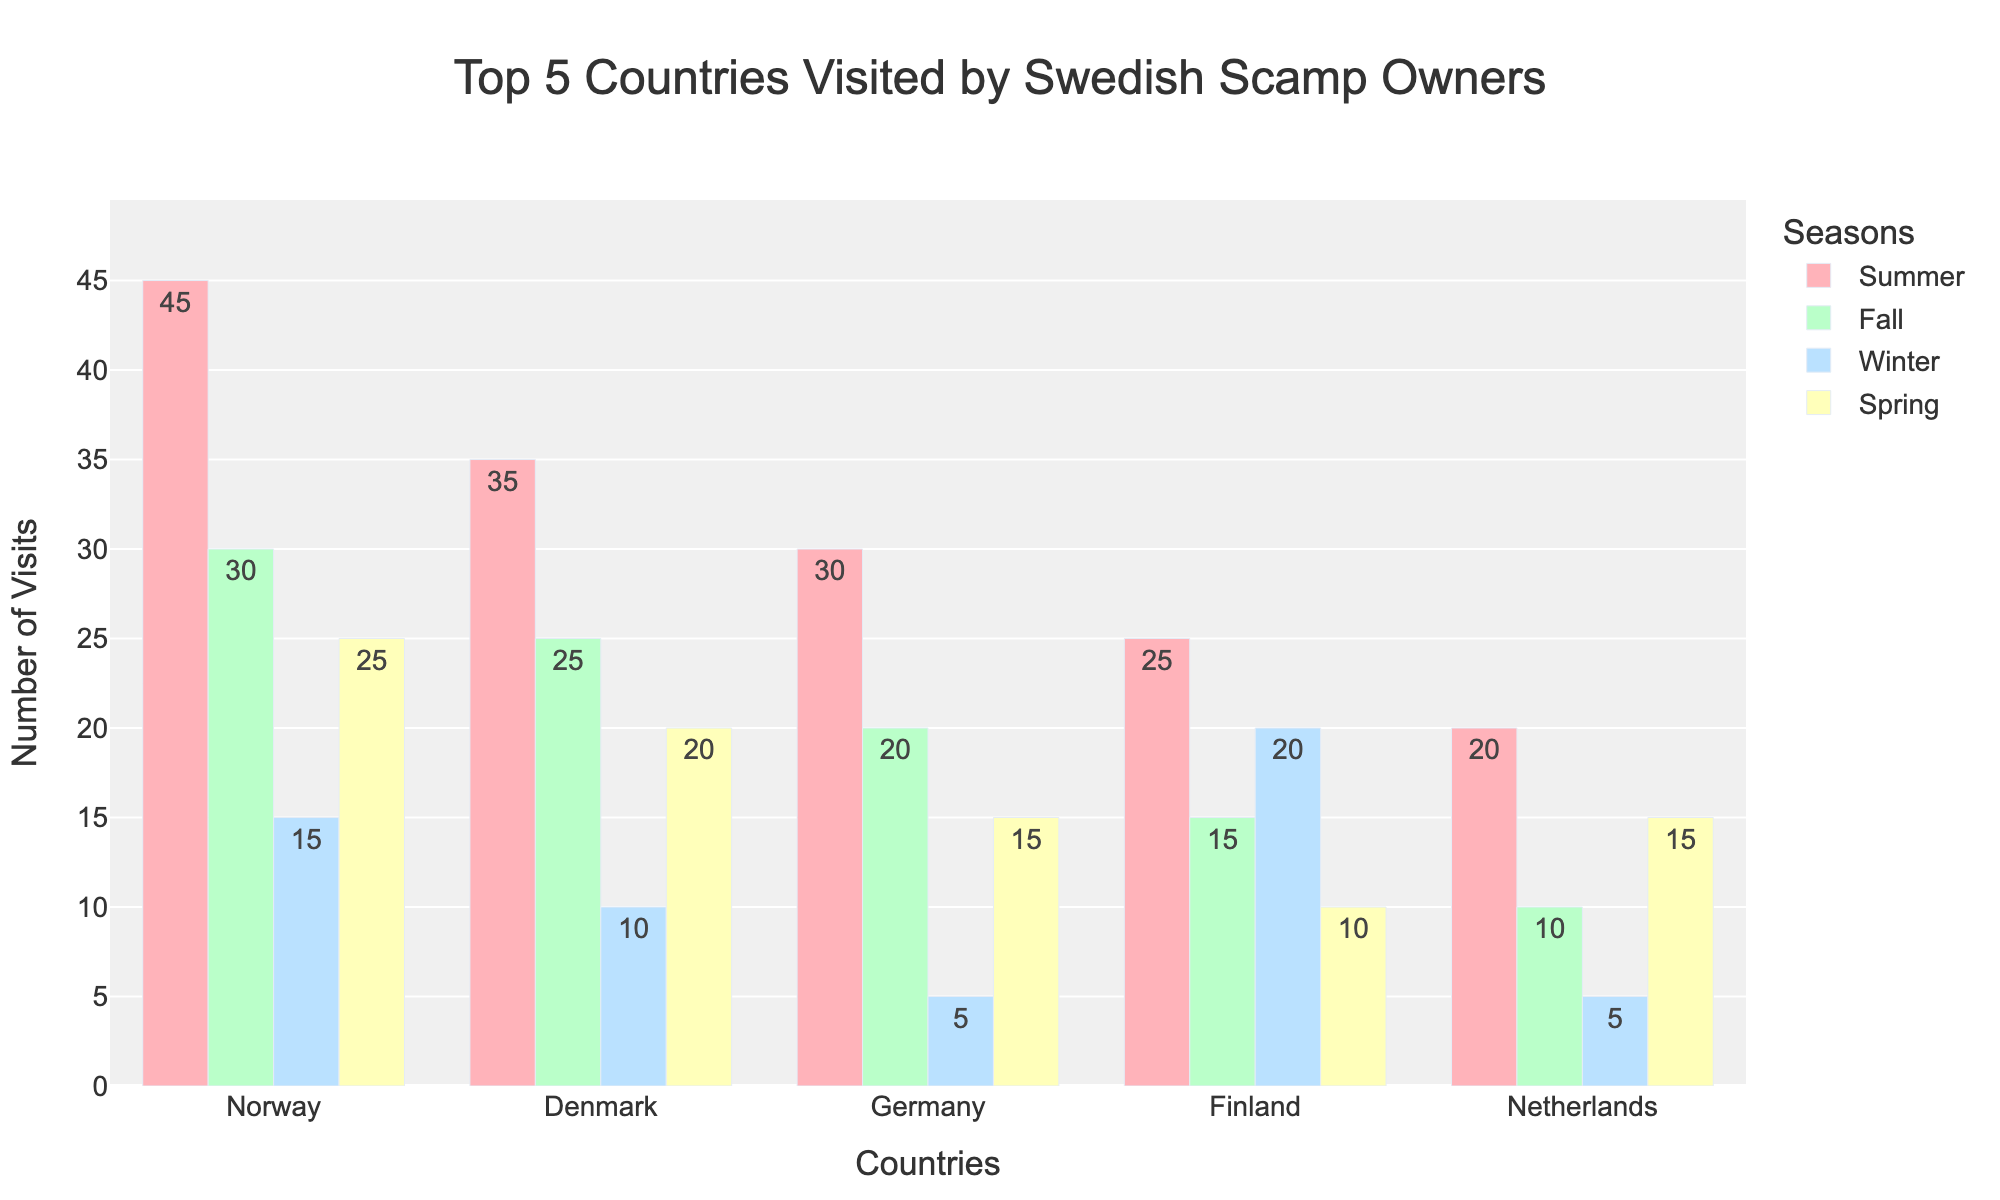Which country has the highest number of visits in Winter? By observing the lengths of the bars corresponding to Winter, we can see that Finland has the longest bar, indicating the highest number of visits.
Answer: Finland How many more visits does Norway have in Summer compared to the Netherlands in Fall? First, observe the Summer visits for Norway, which is 45. Then, observe the Fall visits for the Netherlands, which is 10. The difference is 45 - 10 = 35.
Answer: 35 In which season does Denmark have the least visits? By comparing the heights of the four bars representing Denmark, we can see that the Winter bar is the shortest, indicating the least number of visits.
Answer: Winter What's the total number of visits to Germany across all seasons? Add the number of visits for Germany in all seasons: Summer (30), Fall (20), Winter (5), and Spring (15). The total is 30 + 20 + 5 + 15 = 70.
Answer: 70 Which country has the most balanced number of visits across all seasons? We need to look for the country with bars of similar height across all seasons. By analyzing the chart, Germany appears to have bars of more equal heights compared to other countries.
Answer: Germany Compare Spring visits to Finland and the Netherlands. Which country has more and by how much? First, observe the Spring visits for Finland (10) and the Netherlands (15). The difference is 15 - 10 = 5, so the Netherlands has 5 more visits.
Answer: The Netherlands, 5 Which season has the highest number of total visits across all countries? Sum the visits for each season across all countries. For Summer: 45+35+30+25+20=155. For Fall: 30+25+20+15+10=100. For Winter: 15+10+5+20+5=55. For Spring: 25+20+15+10+15=85. Summer has the highest total.
Answer: Summer What is the difference in total visits between the top-visited and least-visited seasons for Sweden’s Scamp owners? Sum visits for all countries for each season as follows: Summer (45+35+30+25+20=155), Fall (30+25+20+15+10=100), Winter (15+10+5+20+5=55), Spring (25+20+15+10+15=85). The difference between the highest (Summer, 155) and the lowest (Winter, 55) is 155 - 55 = 100.
Answer: 100 